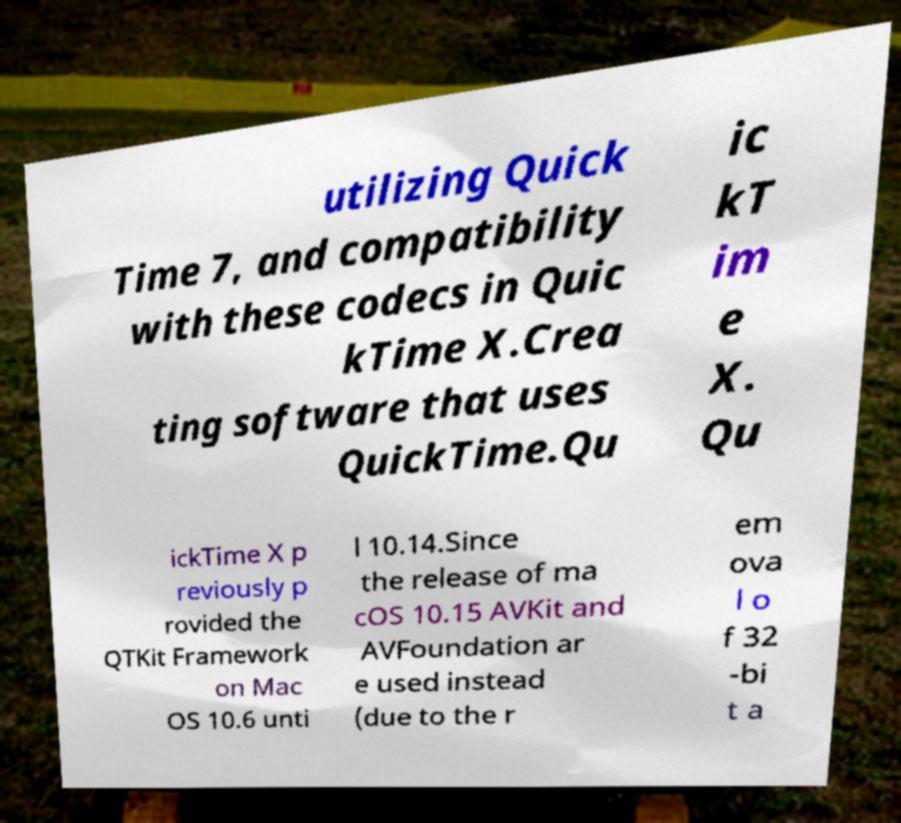Please identify and transcribe the text found in this image. utilizing Quick Time 7, and compatibility with these codecs in Quic kTime X.Crea ting software that uses QuickTime.Qu ic kT im e X. Qu ickTime X p reviously p rovided the QTKit Framework on Mac OS 10.6 unti l 10.14.Since the release of ma cOS 10.15 AVKit and AVFoundation ar e used instead (due to the r em ova l o f 32 -bi t a 